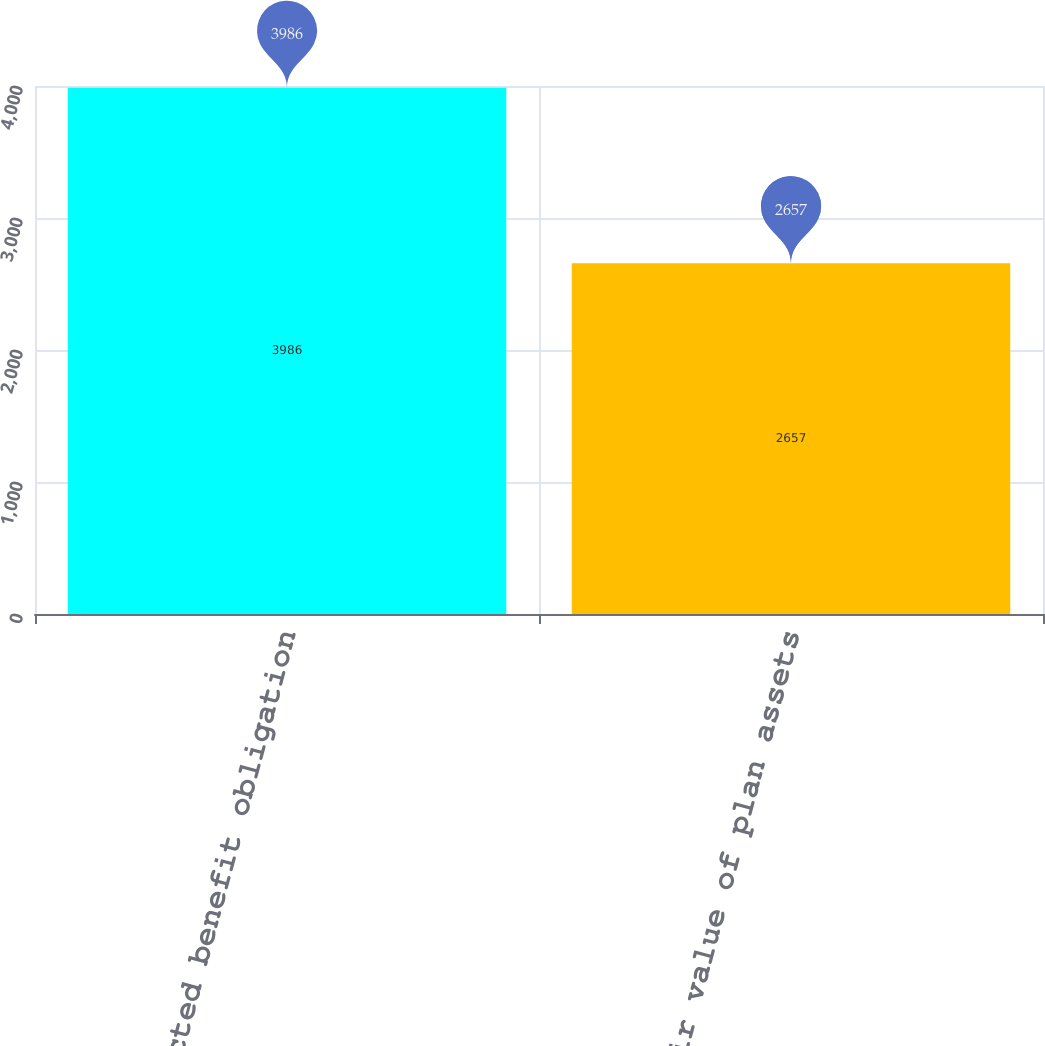<chart> <loc_0><loc_0><loc_500><loc_500><bar_chart><fcel>Projected benefit obligation<fcel>Fair value of plan assets<nl><fcel>3986<fcel>2657<nl></chart> 